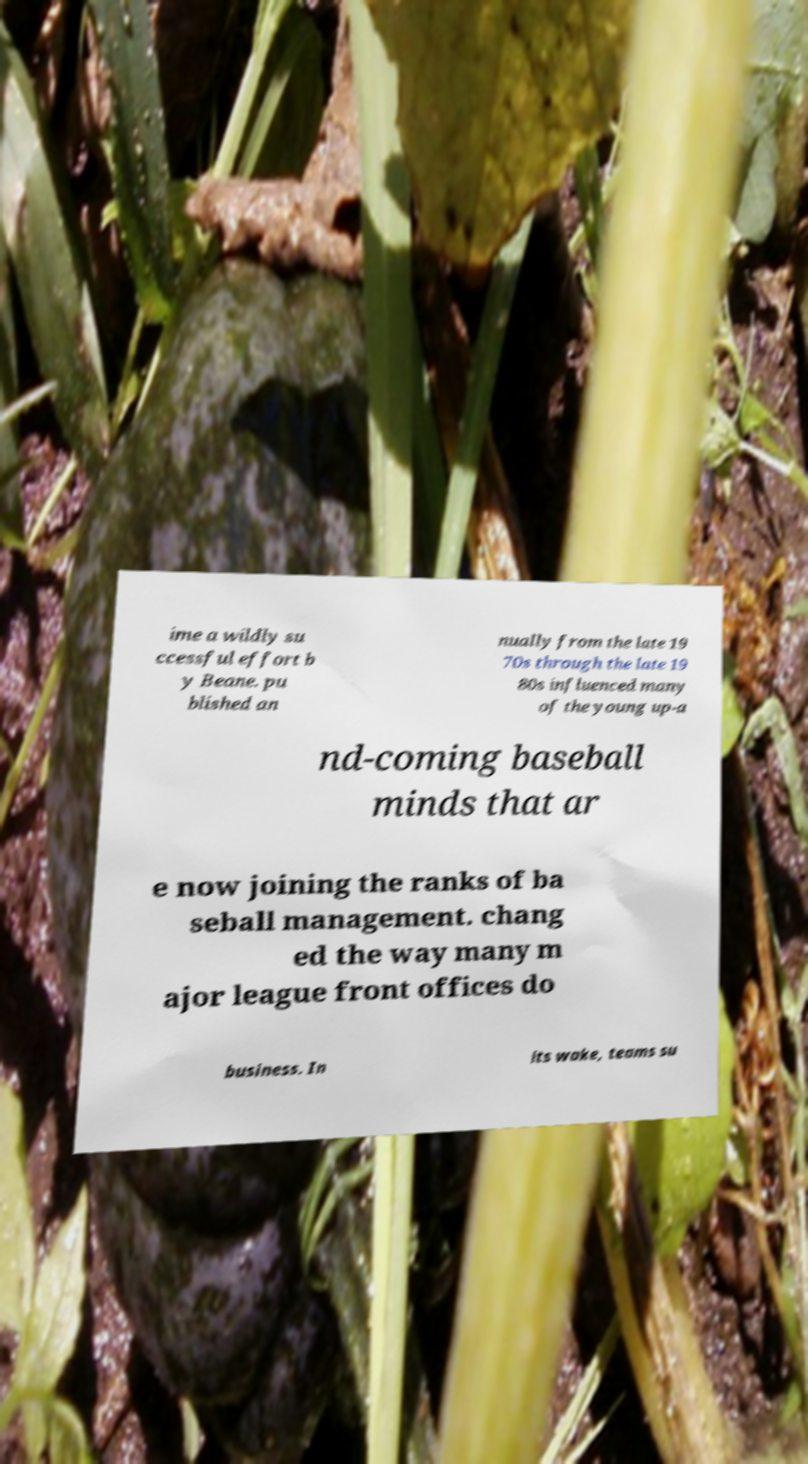Please identify and transcribe the text found in this image. ime a wildly su ccessful effort b y Beane. pu blished an nually from the late 19 70s through the late 19 80s influenced many of the young up-a nd-coming baseball minds that ar e now joining the ranks of ba seball management. chang ed the way many m ajor league front offices do business. In its wake, teams su 